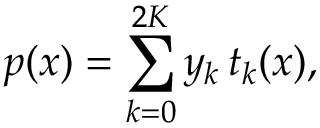Convert formula to latex. <formula><loc_0><loc_0><loc_500><loc_500>p ( x ) = \sum _ { k = 0 } ^ { 2 K } y _ { k } \, t _ { k } ( x ) ,</formula> 